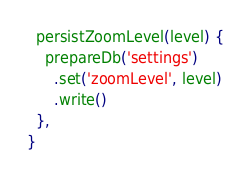<code> <loc_0><loc_0><loc_500><loc_500><_JavaScript_>  persistZoomLevel(level) {
    prepareDb('settings')
      .set('zoomLevel', level)
      .write()
  },
}
</code> 